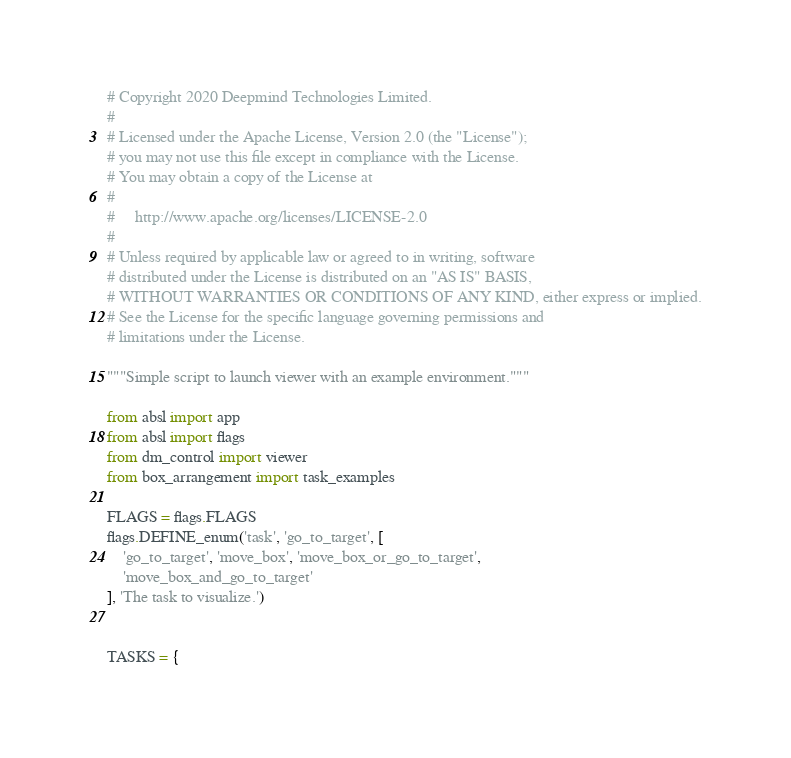Convert code to text. <code><loc_0><loc_0><loc_500><loc_500><_Python_># Copyright 2020 Deepmind Technologies Limited.
#
# Licensed under the Apache License, Version 2.0 (the "License");
# you may not use this file except in compliance with the License.
# You may obtain a copy of the License at
#
#     http://www.apache.org/licenses/LICENSE-2.0
#
# Unless required by applicable law or agreed to in writing, software
# distributed under the License is distributed on an "AS IS" BASIS,
# WITHOUT WARRANTIES OR CONDITIONS OF ANY KIND, either express or implied.
# See the License for the specific language governing permissions and
# limitations under the License.

"""Simple script to launch viewer with an example environment."""

from absl import app
from absl import flags
from dm_control import viewer
from box_arrangement import task_examples

FLAGS = flags.FLAGS
flags.DEFINE_enum('task', 'go_to_target', [
    'go_to_target', 'move_box', 'move_box_or_go_to_target',
    'move_box_and_go_to_target'
], 'The task to visualize.')


TASKS = {</code> 